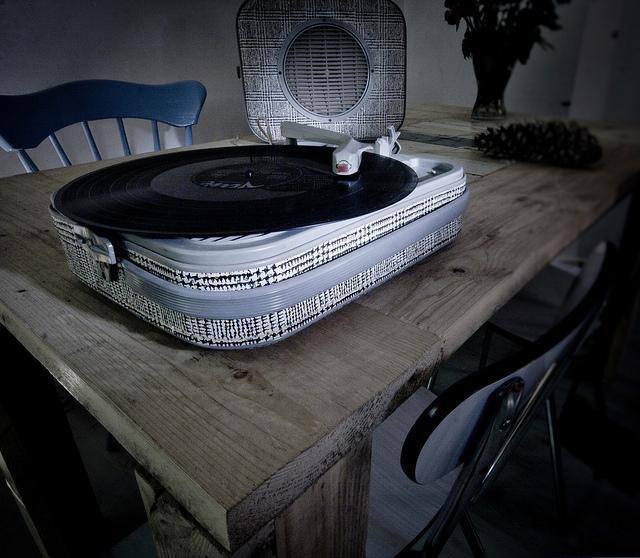How many chairs can be seen?
Give a very brief answer. 2. How many people are wearing blue shirt?
Give a very brief answer. 0. 